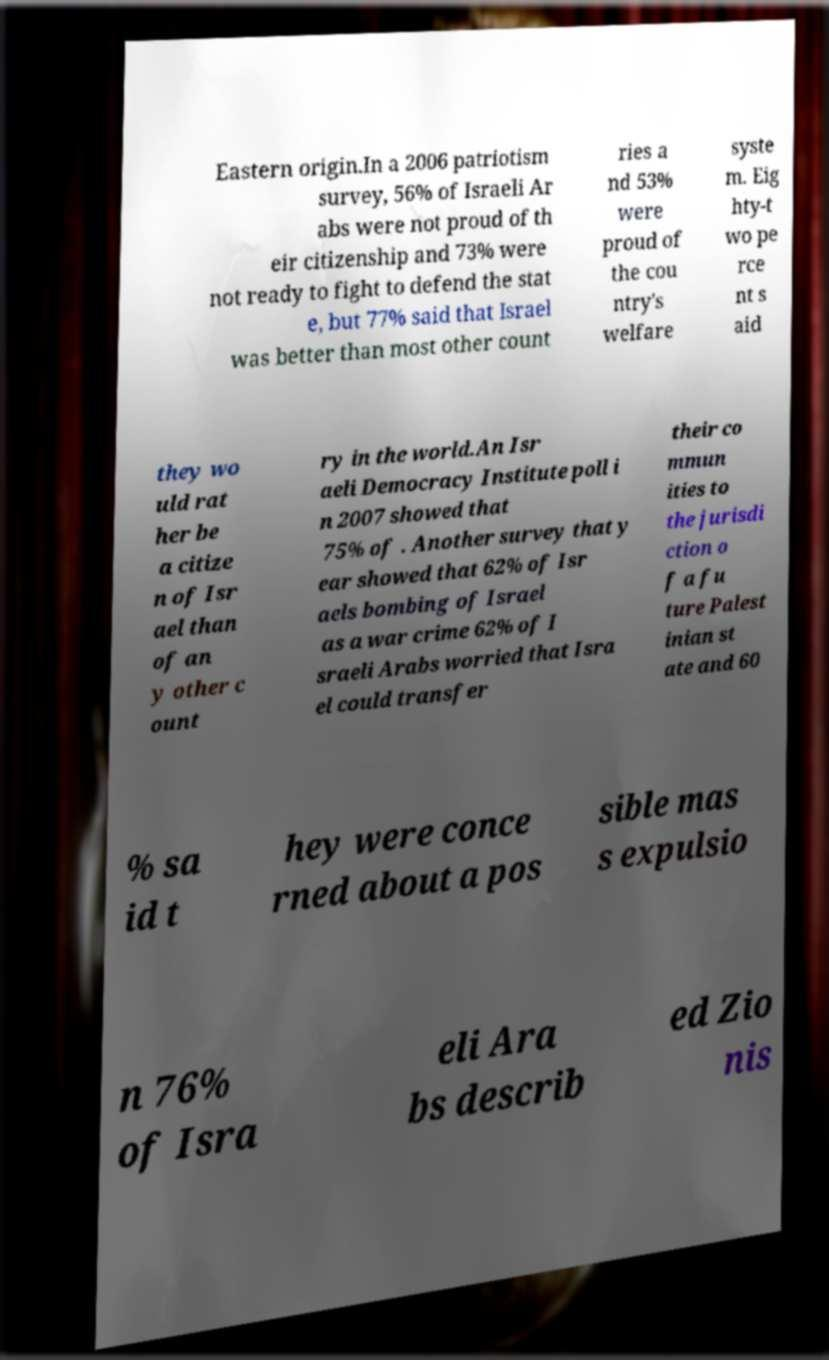Can you read and provide the text displayed in the image?This photo seems to have some interesting text. Can you extract and type it out for me? Eastern origin.In a 2006 patriotism survey, 56% of Israeli Ar abs were not proud of th eir citizenship and 73% were not ready to fight to defend the stat e, but 77% said that Israel was better than most other count ries a nd 53% were proud of the cou ntry's welfare syste m. Eig hty-t wo pe rce nt s aid they wo uld rat her be a citize n of Isr ael than of an y other c ount ry in the world.An Isr aeli Democracy Institute poll i n 2007 showed that 75% of . Another survey that y ear showed that 62% of Isr aels bombing of Israel as a war crime 62% of I sraeli Arabs worried that Isra el could transfer their co mmun ities to the jurisdi ction o f a fu ture Palest inian st ate and 60 % sa id t hey were conce rned about a pos sible mas s expulsio n 76% of Isra eli Ara bs describ ed Zio nis 